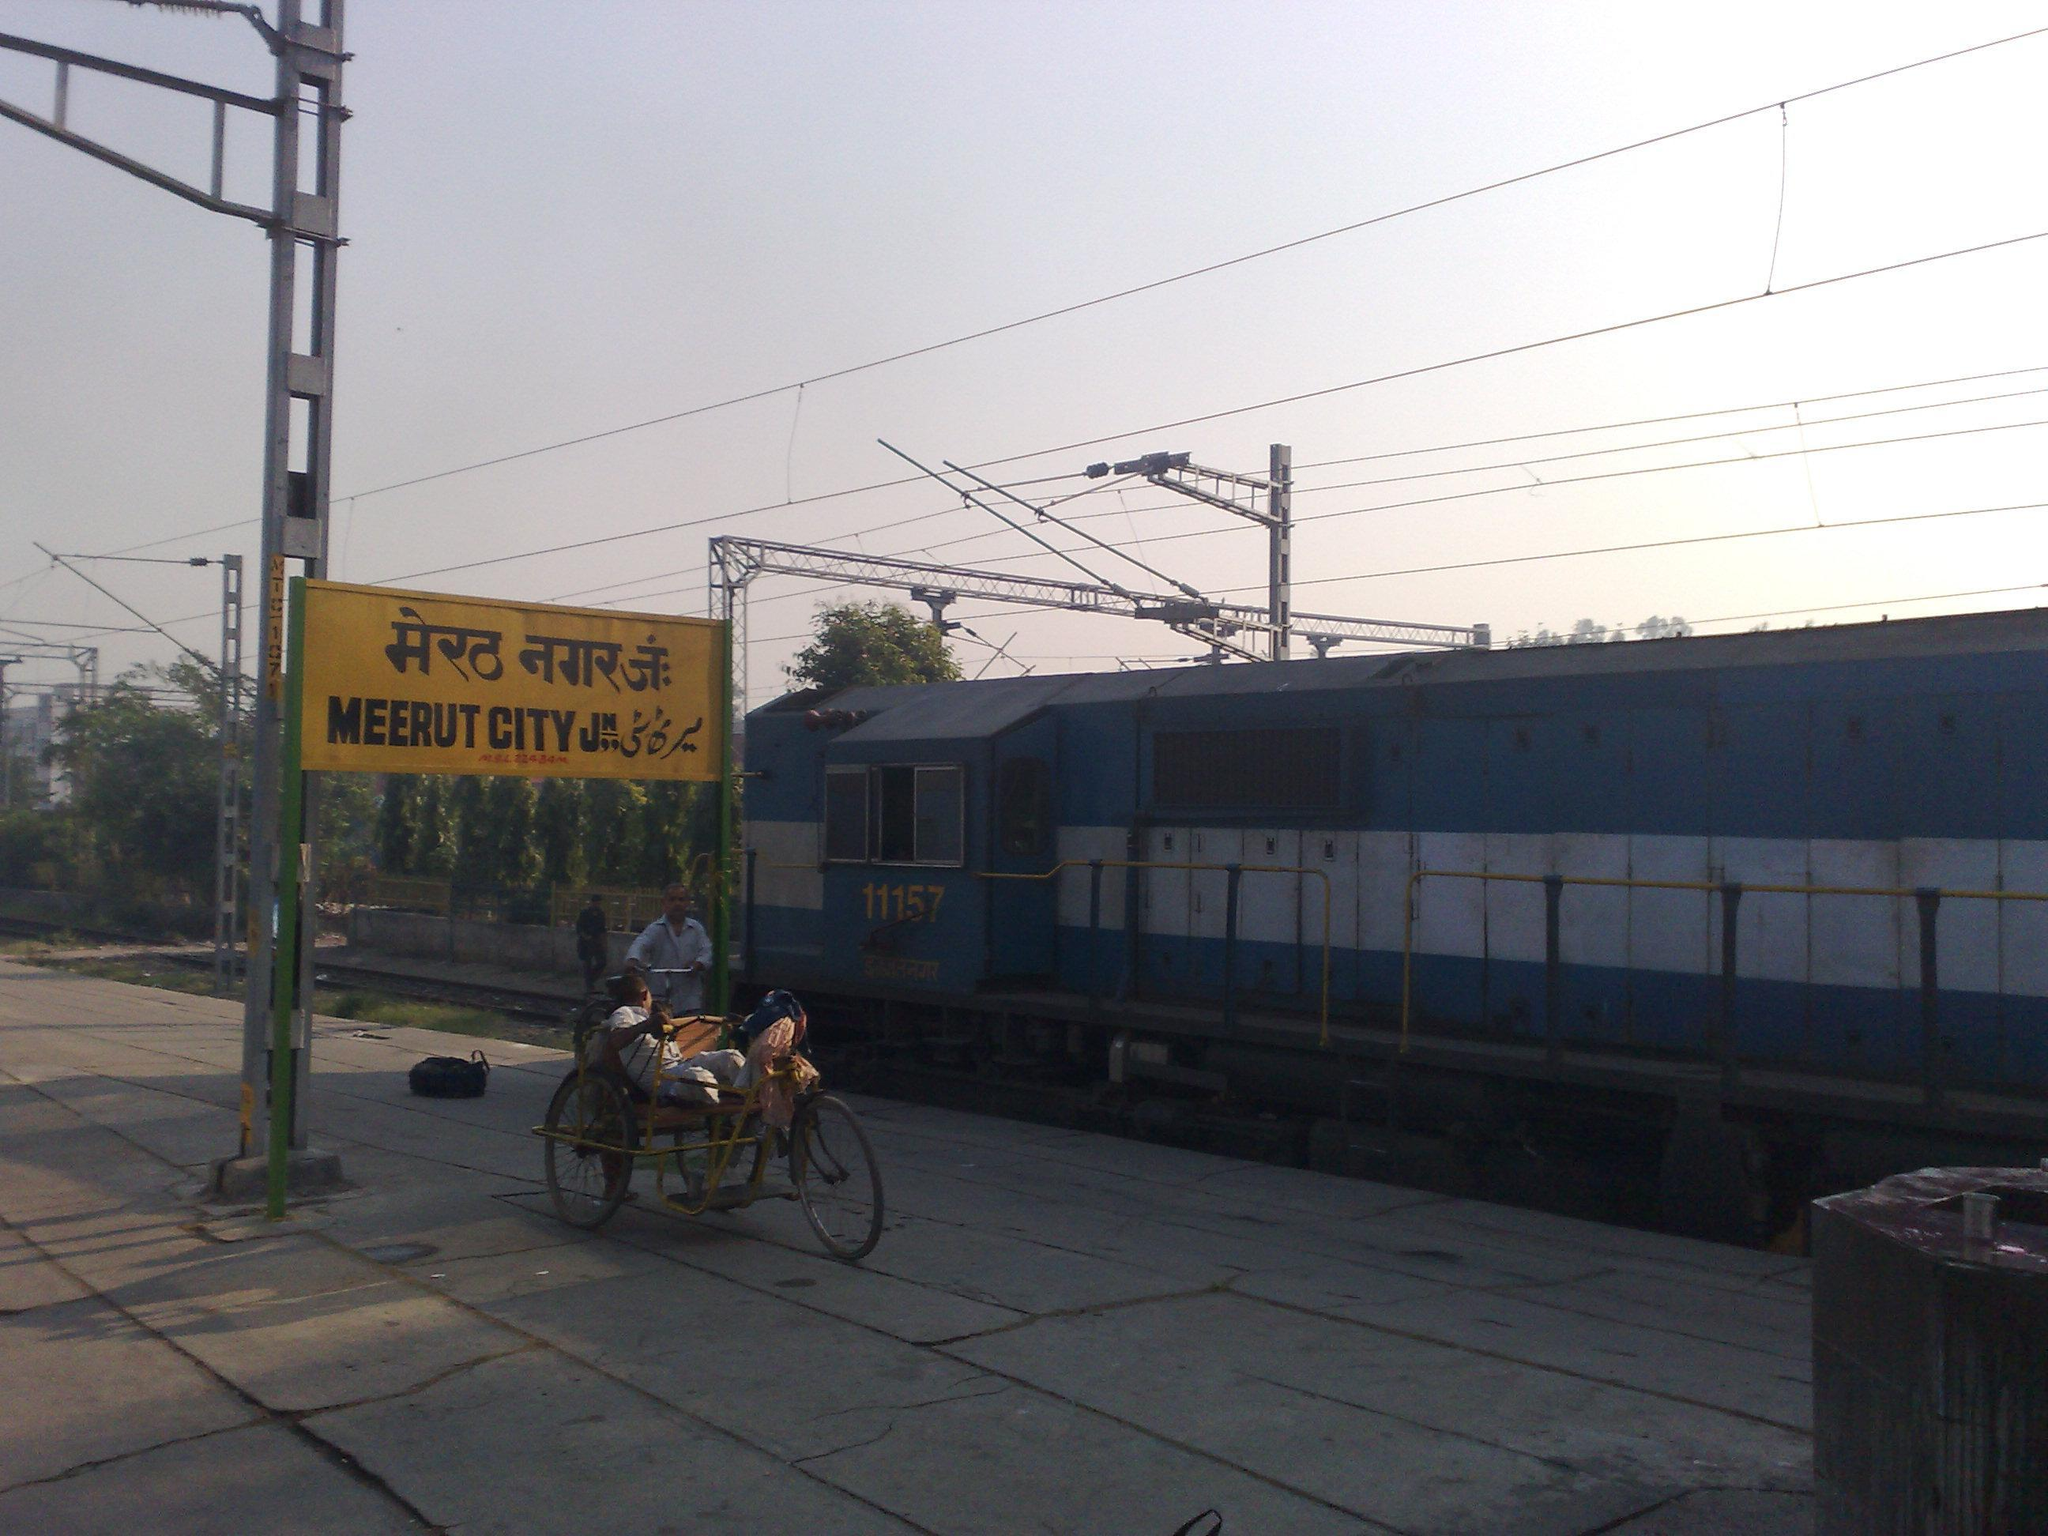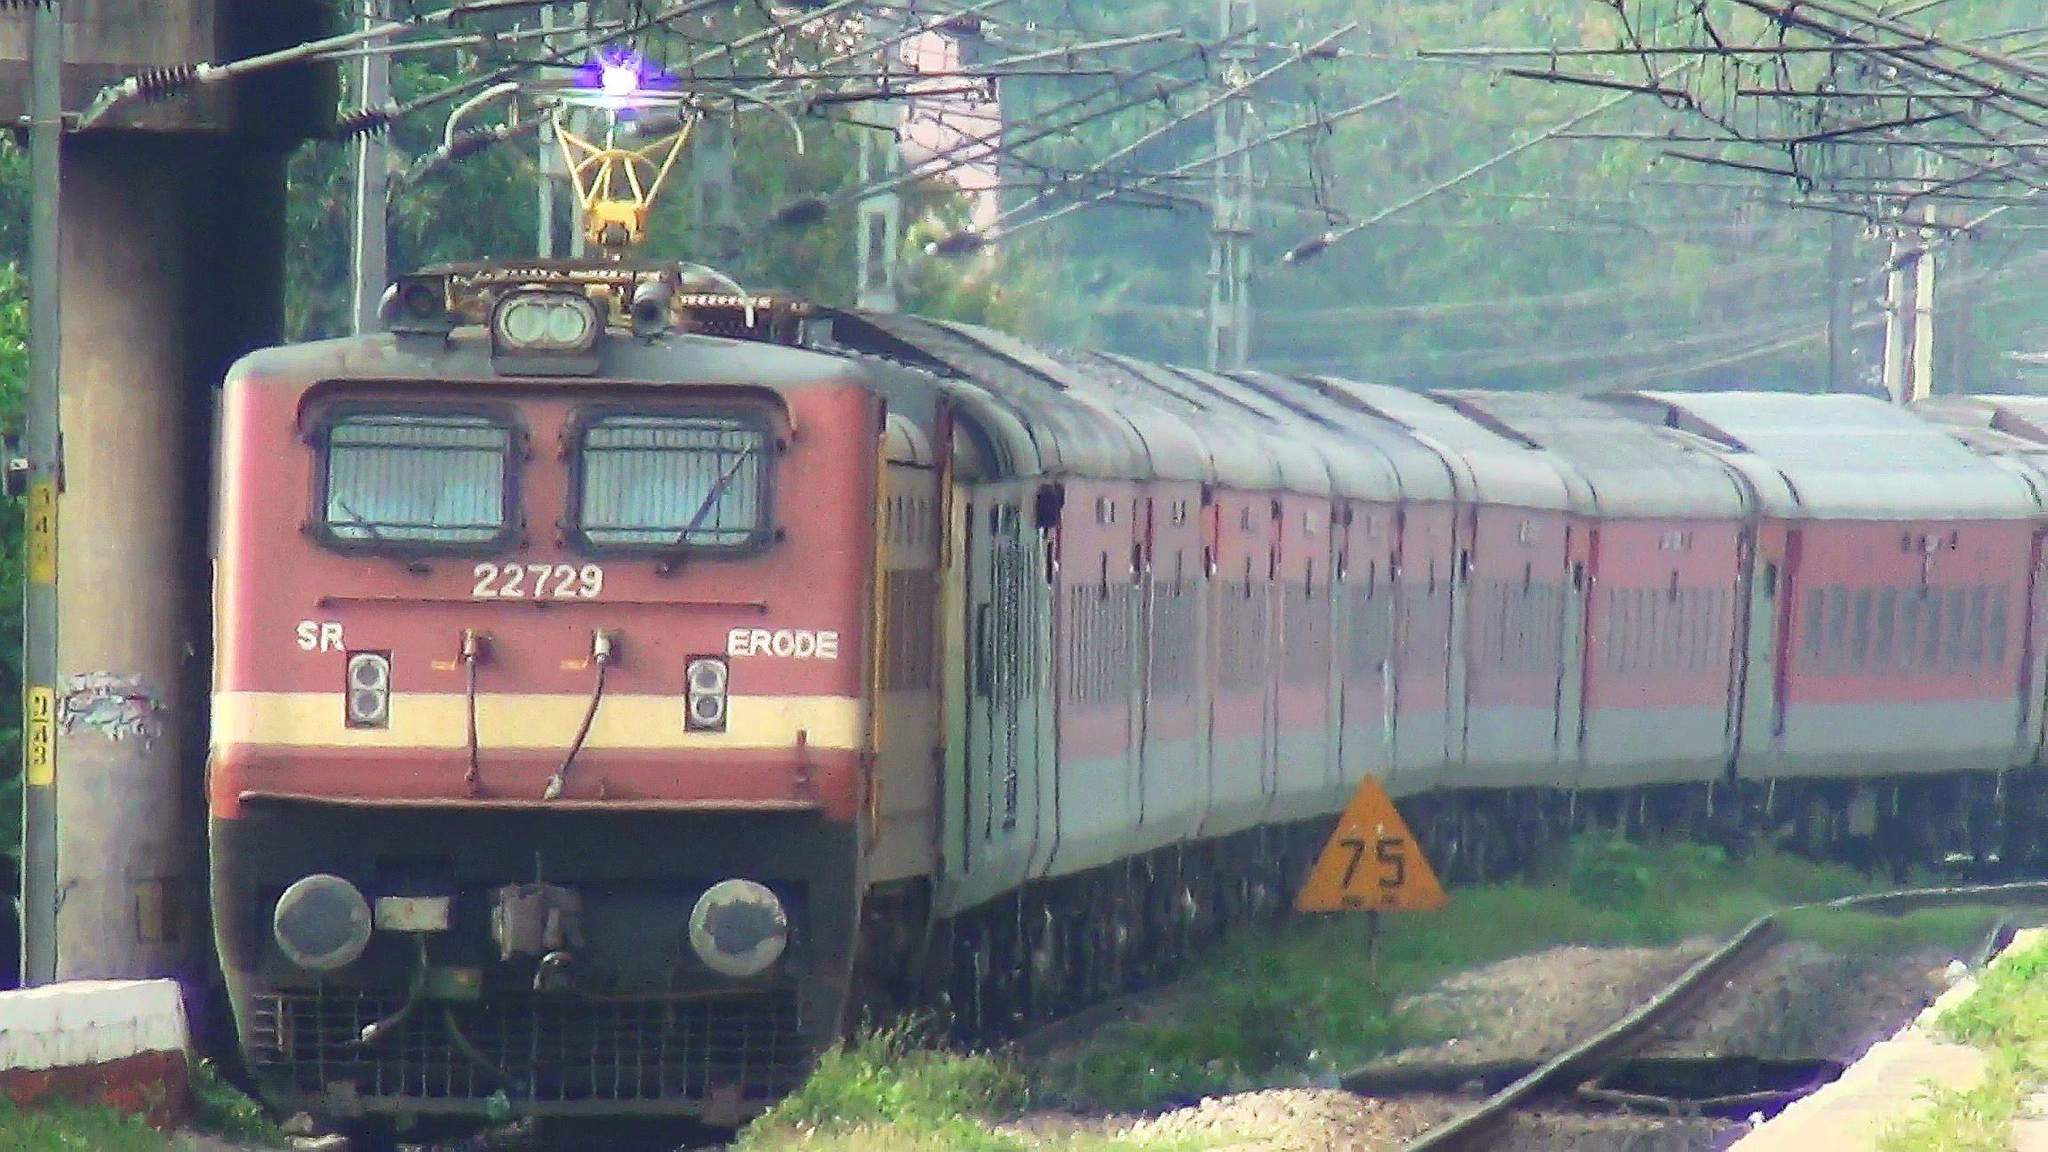The first image is the image on the left, the second image is the image on the right. Given the left and right images, does the statement "An image shows an angled baby-blue train with a yellow stripe, and above the train is a hinged metal contraption." hold true? Answer yes or no. No. The first image is the image on the left, the second image is the image on the right. For the images shown, is this caption "One of the trains is blue with a yellow stripe on it." true? Answer yes or no. No. 